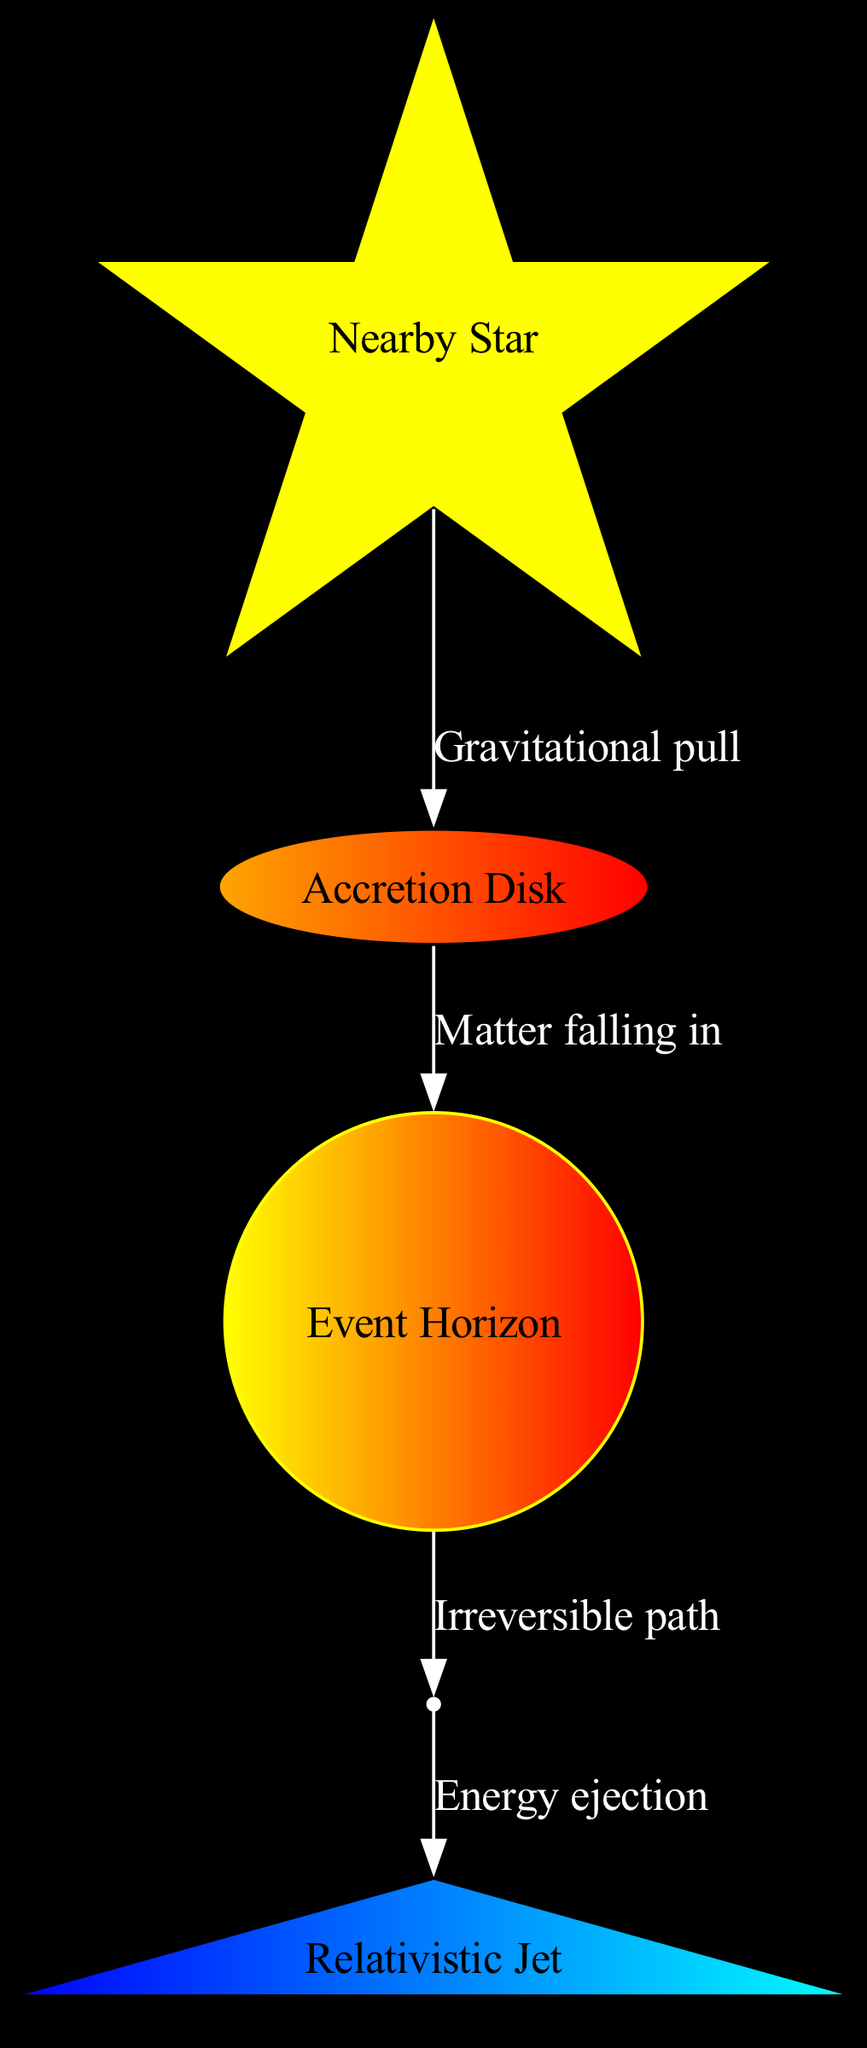What is the event horizon? The event horizon is labeled in the diagram and described as the "Point of no return for light and matter." It is the boundary around a black hole beyond which nothing can escape.
Answer: Point of no return for light and matter How many nodes are present in the diagram? By counting the unique nodes listed in the data, we find five nodes: event horizon, singularity, accretion disk, relativistic jet, and nearby star.
Answer: Five What color represents the accretion disk? The accretion disk is shown as an ellipse and filled with a gradient from orange to red. The color designation is specific to how it is visually depicted in the diagram.
Answer: Orange to red What does the arrow from the accretion disk to the event horizon indicate? The arrow indicates "Matter falling in," signifying the process by which matter from the accretion disk is drawn into the black hole past the event horizon.
Answer: Matter falling in Which node is described as the infinitely dense center of the black hole? The singularity is labeled in the diagram and is defined as the "Infinitely dense center of the black hole." This is a key attribute of black holes.
Answer: Singularity What is emitted from the singularity according to the diagram? The diagram shows that the singularity is associated with the emission of a "Relativistic Jet," which represents high-energy particle streams that are ejected from the poles of the black hole.
Answer: Relativistic Jet Which celestial body is affected by the gravitational pull of the black hole? The node labeled "Nearby Star" is shown with an arrow indicating "Gravitational pull," illustrating how the black hole's gravity influences this star.
Answer: Nearby Star What relationship is depicted between the nearby star and the accretion disk? The diagram illustrates a directional edge between the nearby star and the accretion disk labeled "Gravitational pull," highlighting the influence of the black hole's gravity on the nearby star's position and movement.
Answer: Gravitational pull What is the relationship between the singularity and the jet? The diagram indicates an edge from the singularity to the relativistic jet, labeled "Energy ejection," which signifies how energy is released from the black hole in the form of jets of particles.
Answer: Energy ejection 